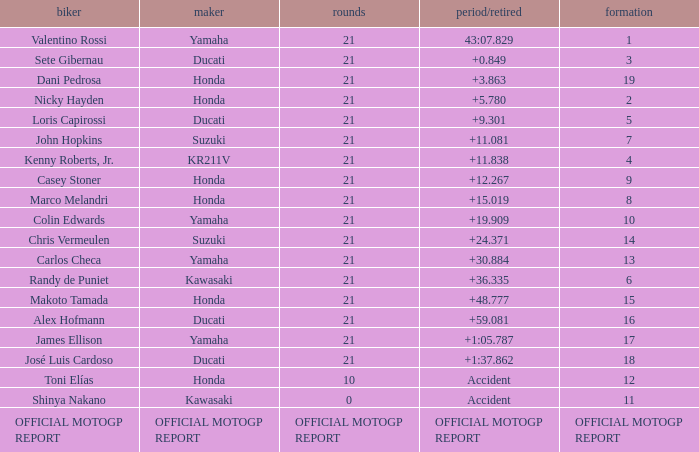WWhich rder had a vehicle manufactured by kr211v? Kenny Roberts, Jr. 